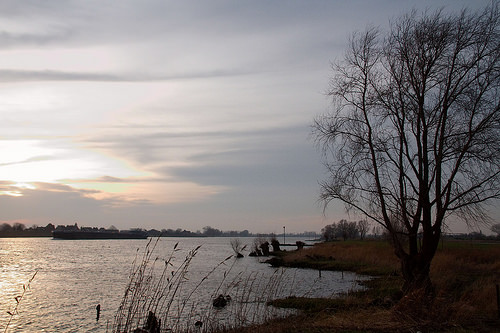<image>
Can you confirm if the water is under the tree? Yes. The water is positioned underneath the tree, with the tree above it in the vertical space. 